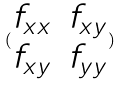Convert formula to latex. <formula><loc_0><loc_0><loc_500><loc_500>( \begin{matrix} f _ { x x } & f _ { x y } \\ f _ { x y } & f _ { y y } \end{matrix} )</formula> 